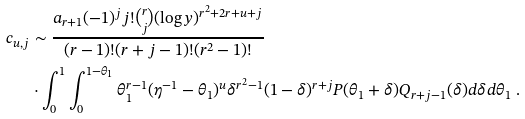Convert formula to latex. <formula><loc_0><loc_0><loc_500><loc_500>c _ { u , j } & \sim \frac { a _ { r + 1 } ( - 1 ) ^ { j } j ! \binom { r } { j } ( \log y ) ^ { r ^ { 2 } + 2 r + u + j } } { ( r - 1 ) ! ( r + j - 1 ) ! ( r ^ { 2 } - 1 ) ! } \\ & \cdot \int _ { 0 } ^ { 1 } \int _ { 0 } ^ { 1 - \theta _ { 1 } } \theta _ { 1 } ^ { r - 1 } ( \eta ^ { - 1 } - \theta _ { 1 } ) ^ { u } \delta ^ { r ^ { 2 } - 1 } ( 1 - \delta ) ^ { r + j } P ( \theta _ { 1 } + \delta ) Q _ { r + j - 1 } ( \delta ) d \delta d \theta _ { 1 } \ .</formula> 